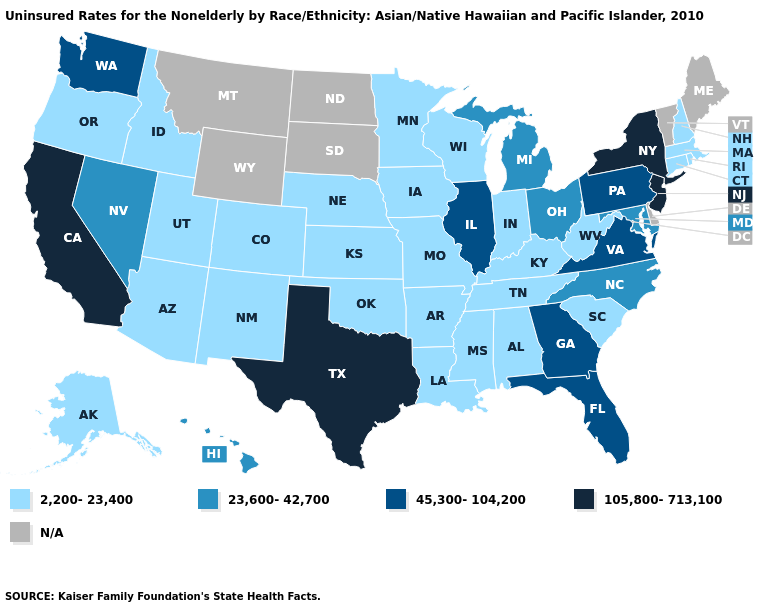What is the value of Wyoming?
Give a very brief answer. N/A. Does Illinois have the lowest value in the MidWest?
Concise answer only. No. Name the states that have a value in the range 23,600-42,700?
Keep it brief. Hawaii, Maryland, Michigan, Nevada, North Carolina, Ohio. Which states have the lowest value in the South?
Keep it brief. Alabama, Arkansas, Kentucky, Louisiana, Mississippi, Oklahoma, South Carolina, Tennessee, West Virginia. What is the value of Minnesota?
Give a very brief answer. 2,200-23,400. Does West Virginia have the highest value in the South?
Concise answer only. No. What is the value of Vermont?
Answer briefly. N/A. Among the states that border Idaho , does Utah have the highest value?
Quick response, please. No. Name the states that have a value in the range N/A?
Quick response, please. Delaware, Maine, Montana, North Dakota, South Dakota, Vermont, Wyoming. Name the states that have a value in the range 23,600-42,700?
Write a very short answer. Hawaii, Maryland, Michigan, Nevada, North Carolina, Ohio. What is the value of Maine?
Short answer required. N/A. Is the legend a continuous bar?
Give a very brief answer. No. Does the map have missing data?
Be succinct. Yes. 